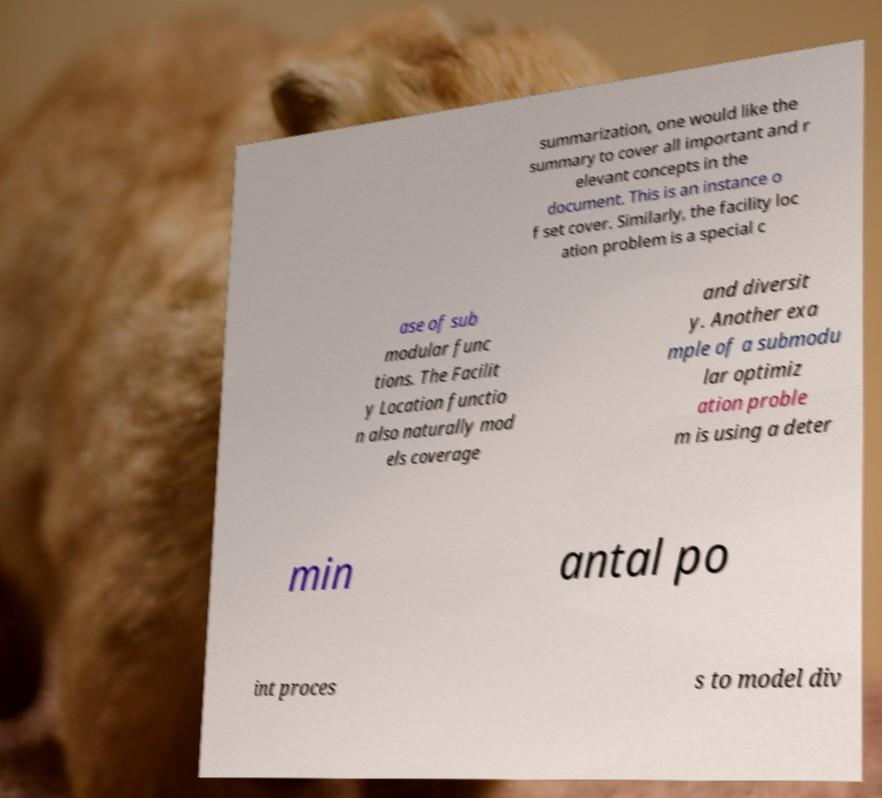Please read and relay the text visible in this image. What does it say? summarization, one would like the summary to cover all important and r elevant concepts in the document. This is an instance o f set cover. Similarly, the facility loc ation problem is a special c ase of sub modular func tions. The Facilit y Location functio n also naturally mod els coverage and diversit y. Another exa mple of a submodu lar optimiz ation proble m is using a deter min antal po int proces s to model div 